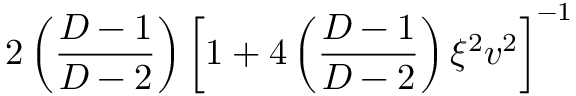<formula> <loc_0><loc_0><loc_500><loc_500>2 \left ( \frac { D - 1 } { D - 2 } \right ) \left [ 1 + 4 \left ( \frac { D - 1 } { D - 2 } \right ) \xi ^ { 2 } v ^ { 2 } \right ] ^ { - 1 }</formula> 